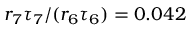Convert formula to latex. <formula><loc_0><loc_0><loc_500><loc_500>r _ { 7 } \tau _ { 7 } / ( r _ { 6 } \tau _ { 6 } ) = 0 . 0 4 2</formula> 